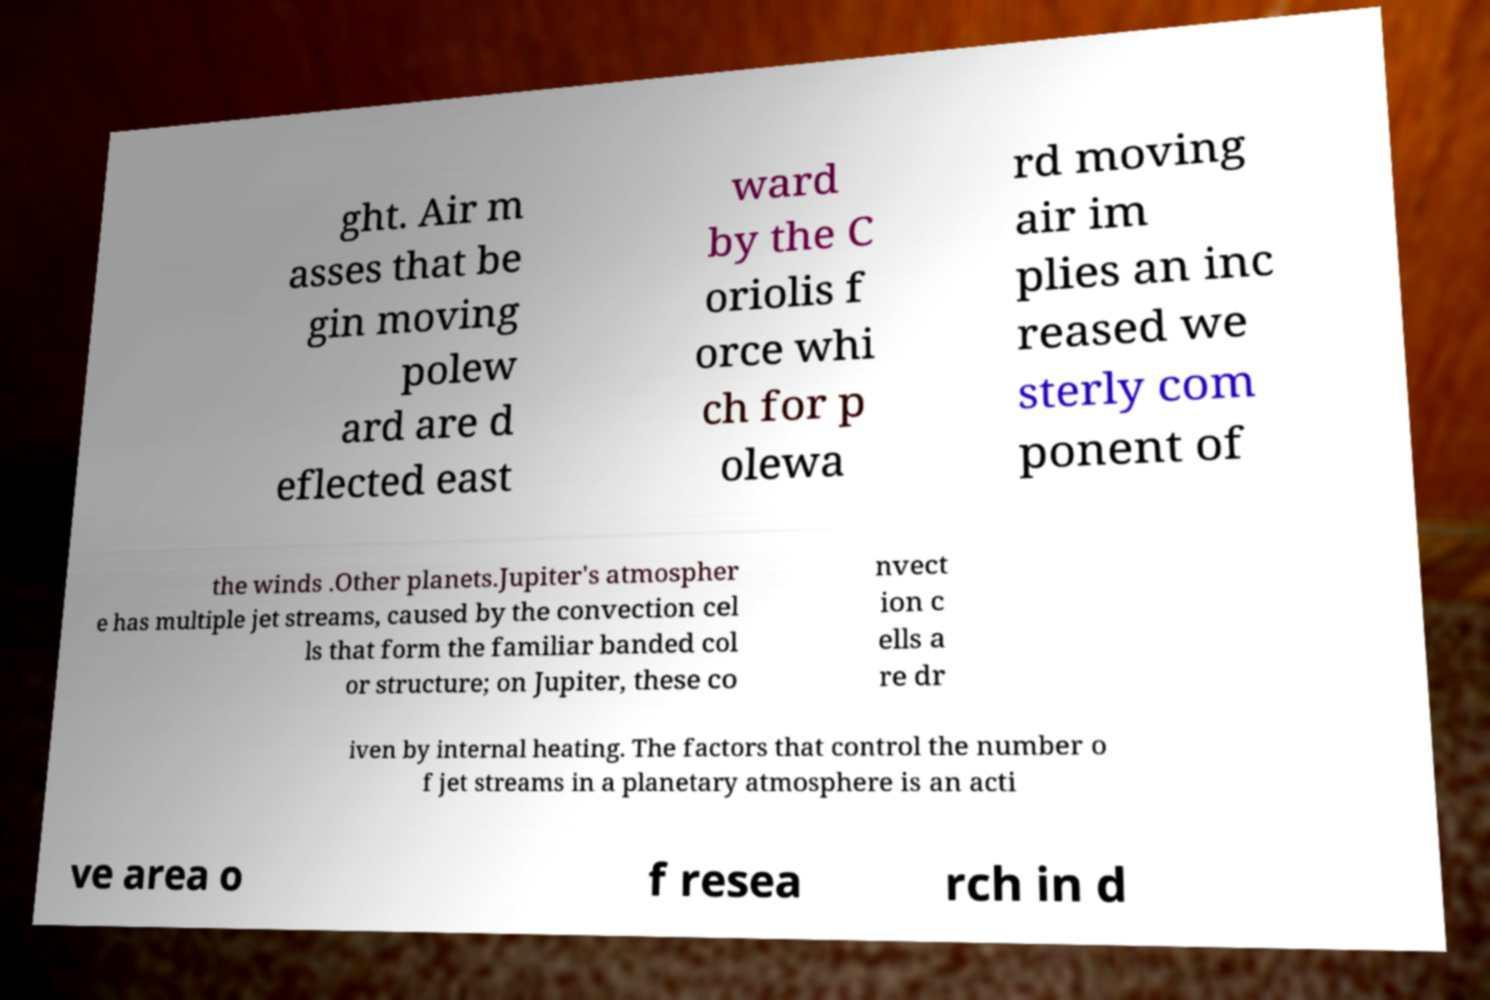Can you accurately transcribe the text from the provided image for me? ght. Air m asses that be gin moving polew ard are d eflected east ward by the C oriolis f orce whi ch for p olewa rd moving air im plies an inc reased we sterly com ponent of the winds .Other planets.Jupiter's atmospher e has multiple jet streams, caused by the convection cel ls that form the familiar banded col or structure; on Jupiter, these co nvect ion c ells a re dr iven by internal heating. The factors that control the number o f jet streams in a planetary atmosphere is an acti ve area o f resea rch in d 